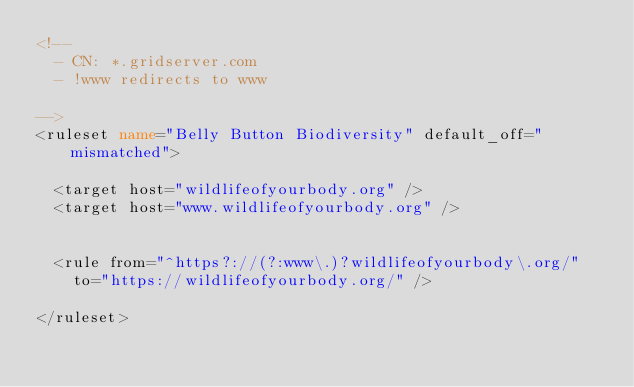<code> <loc_0><loc_0><loc_500><loc_500><_XML_><!--
	- CN: *.gridserver.com
	- !www redirects to www

-->
<ruleset name="Belly Button Biodiversity" default_off="mismatched">

	<target host="wildlifeofyourbody.org" />
	<target host="www.wildlifeofyourbody.org" />


	<rule from="^https?://(?:www\.)?wildlifeofyourbody\.org/"
		to="https://wildlifeofyourbody.org/" />

</ruleset></code> 